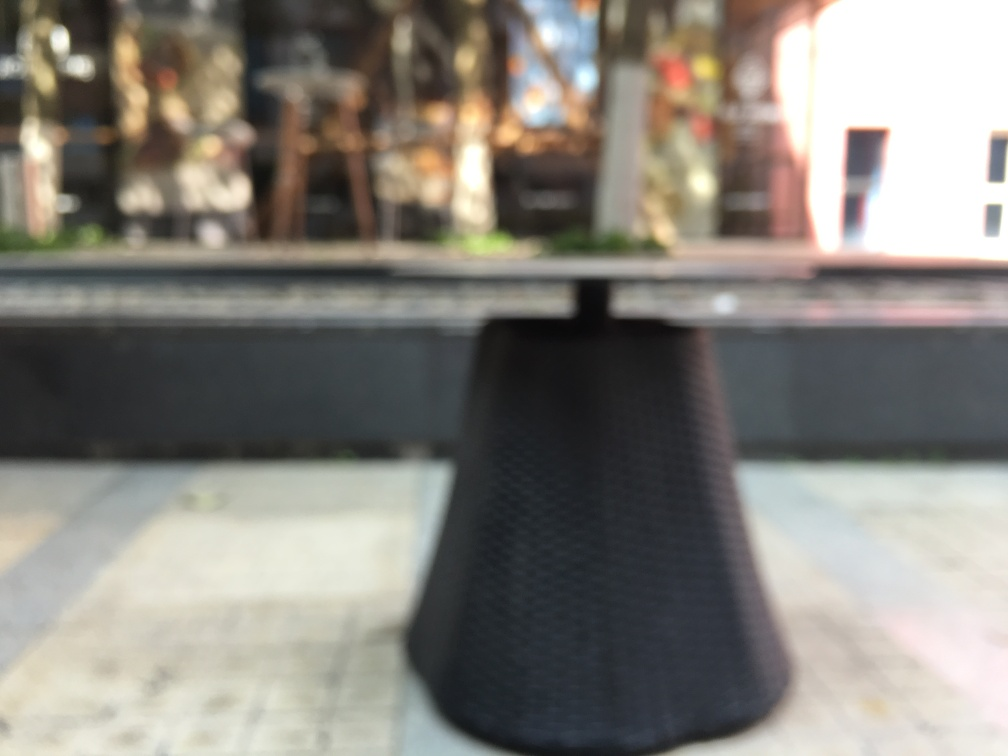Has the main subject, the table, lost a significant amount of texture detail? Option A is correct; the image displays a noticeable loss of texture detail on the surface of the main subject, which is the table. The blur affects its clarity, preventing us from discerning the specific textures and features of the table's material. 